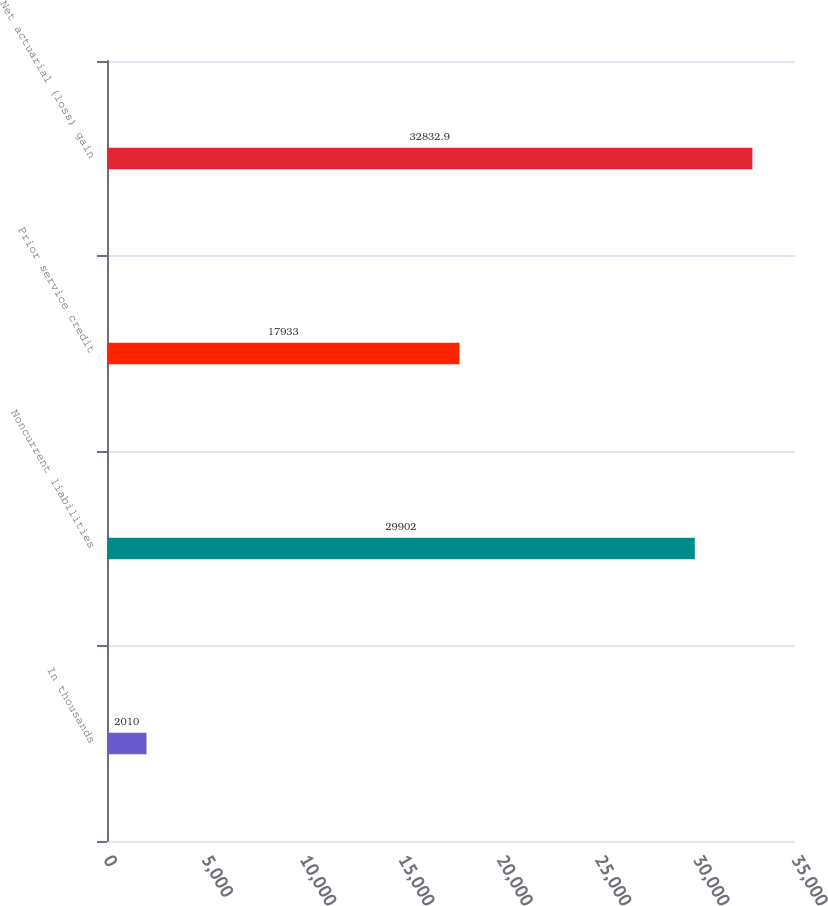Convert chart. <chart><loc_0><loc_0><loc_500><loc_500><bar_chart><fcel>In thousands<fcel>Noncurrent liabilities<fcel>Prior service credit<fcel>Net actuarial (loss) gain<nl><fcel>2010<fcel>29902<fcel>17933<fcel>32832.9<nl></chart> 